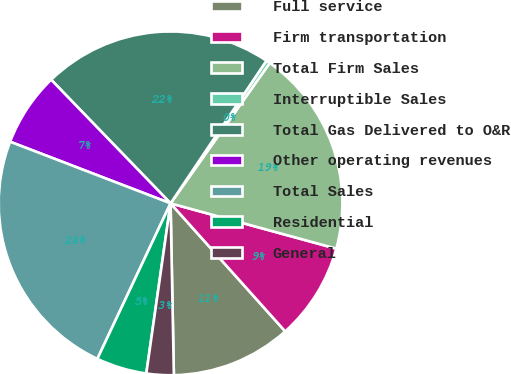<chart> <loc_0><loc_0><loc_500><loc_500><pie_chart><fcel>Full service<fcel>Firm transportation<fcel>Total Firm Sales<fcel>Interruptible Sales<fcel>Total Gas Delivered to O&R<fcel>Other operating revenues<fcel>Total Sales<fcel>Residential<fcel>General<nl><fcel>11.32%<fcel>9.13%<fcel>19.46%<fcel>0.37%<fcel>21.65%<fcel>6.94%<fcel>23.84%<fcel>4.75%<fcel>2.56%<nl></chart> 